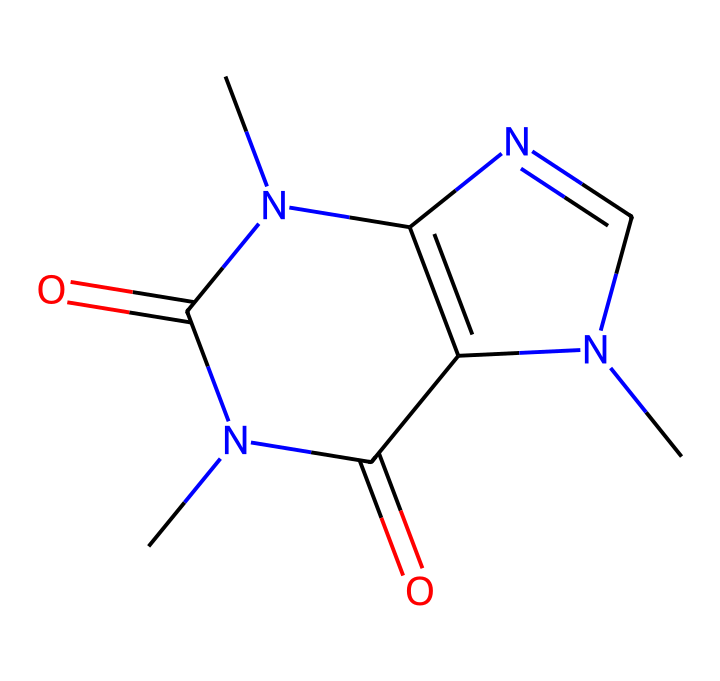What is the molecular formula of caffeine? To determine the molecular formula, we analyze the SMILES string, counting each type of atom (C, H, N, O). From the structure, we find there are 8 carbon (C), 10 hydrogen (H), 4 nitrogen (N), and 2 oxygen (O) atoms. Thus, the molecular formula is C8H10N4O2.
Answer: C8H10N4O2 How many nitrogen atoms are present in the structure? By examining the SMILES representation, we can identify and count the nitrogen (N) atoms, which are specifically highlighted with their symbols. In the given structure, there are four nitrogen (N) atoms clearly present.
Answer: 4 Does caffeine have any functional groups? The structure includes carbonyl (C=O) groups, which classify as functional groups. Observing the arrangement, the two nitrogen atoms also indicate the presence of amine functional groups. Hence, caffeine has carbonyl and amine groups.
Answer: yes What types of rings are present in the caffeine structure? Analyzing the SMILES, we note the presence of two fused rings in the structure. The notation 'N1' and 'N2' indicate the presence of two separate ring systems that share two nitrogen atoms, forming a bicyclic compound.
Answer: bicyclic How many double bonds are in the caffeine molecule? In the structure, we observe that the carbonyl (C=O) bonds indicate double bonds. Counting these, we note there are three double bonds throughout the chemical, specifically two carbonyl and one C=N bond.
Answer: 3 What is the primary classification of caffeine based on its structure? By closely analyzing the nitrogenous base structure, caffeine fits into the category of purines due to the arrangement of carbon and nitrogen atoms in a bicyclic structure. This classification relates to its function and features as a stimulant.
Answer: purine 